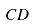Convert formula to latex. <formula><loc_0><loc_0><loc_500><loc_500>C D</formula> 